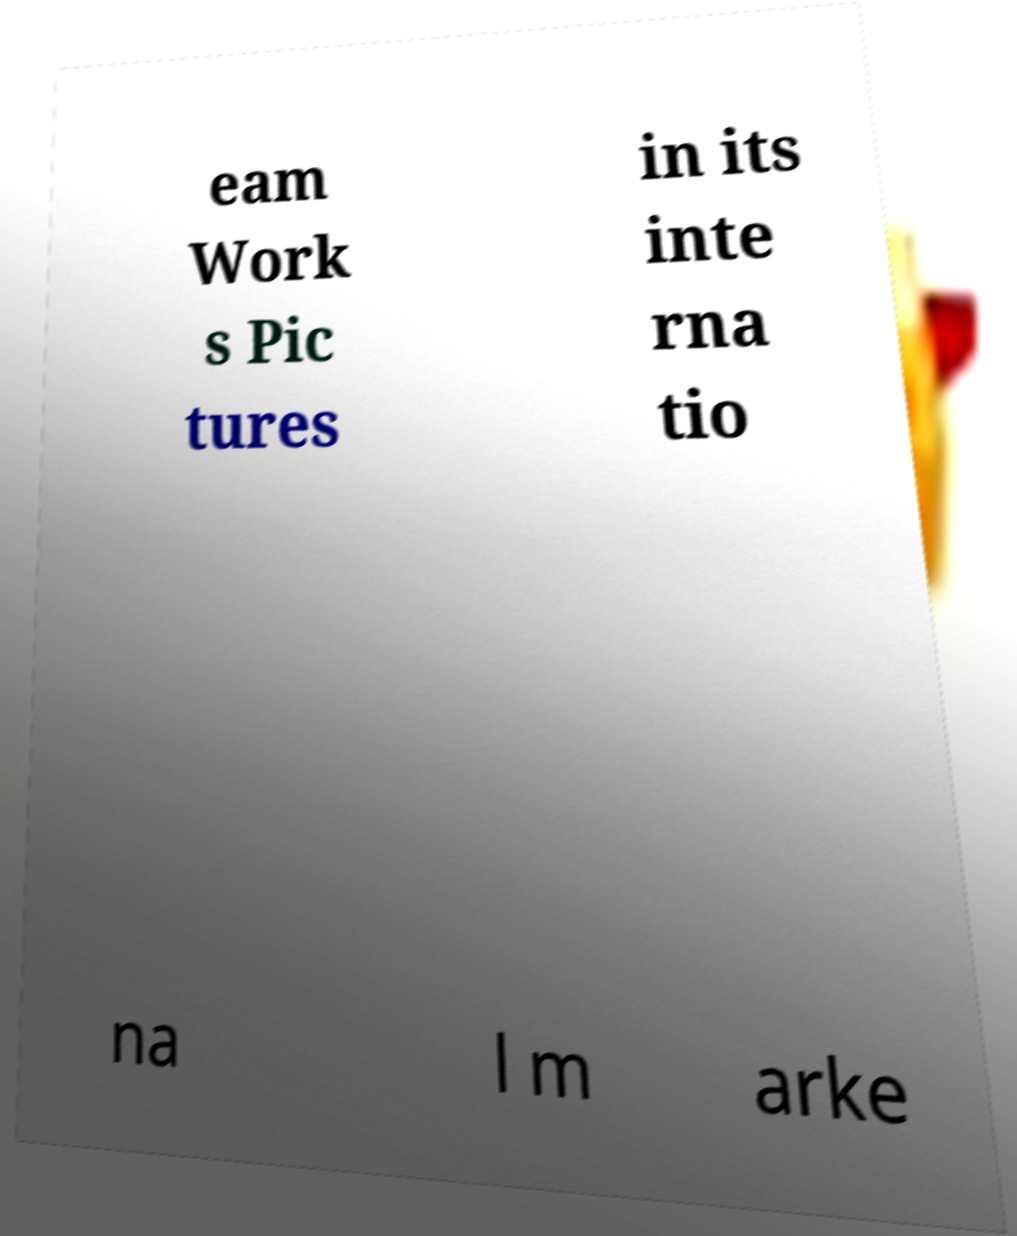Can you read and provide the text displayed in the image?This photo seems to have some interesting text. Can you extract and type it out for me? eam Work s Pic tures in its inte rna tio na l m arke 